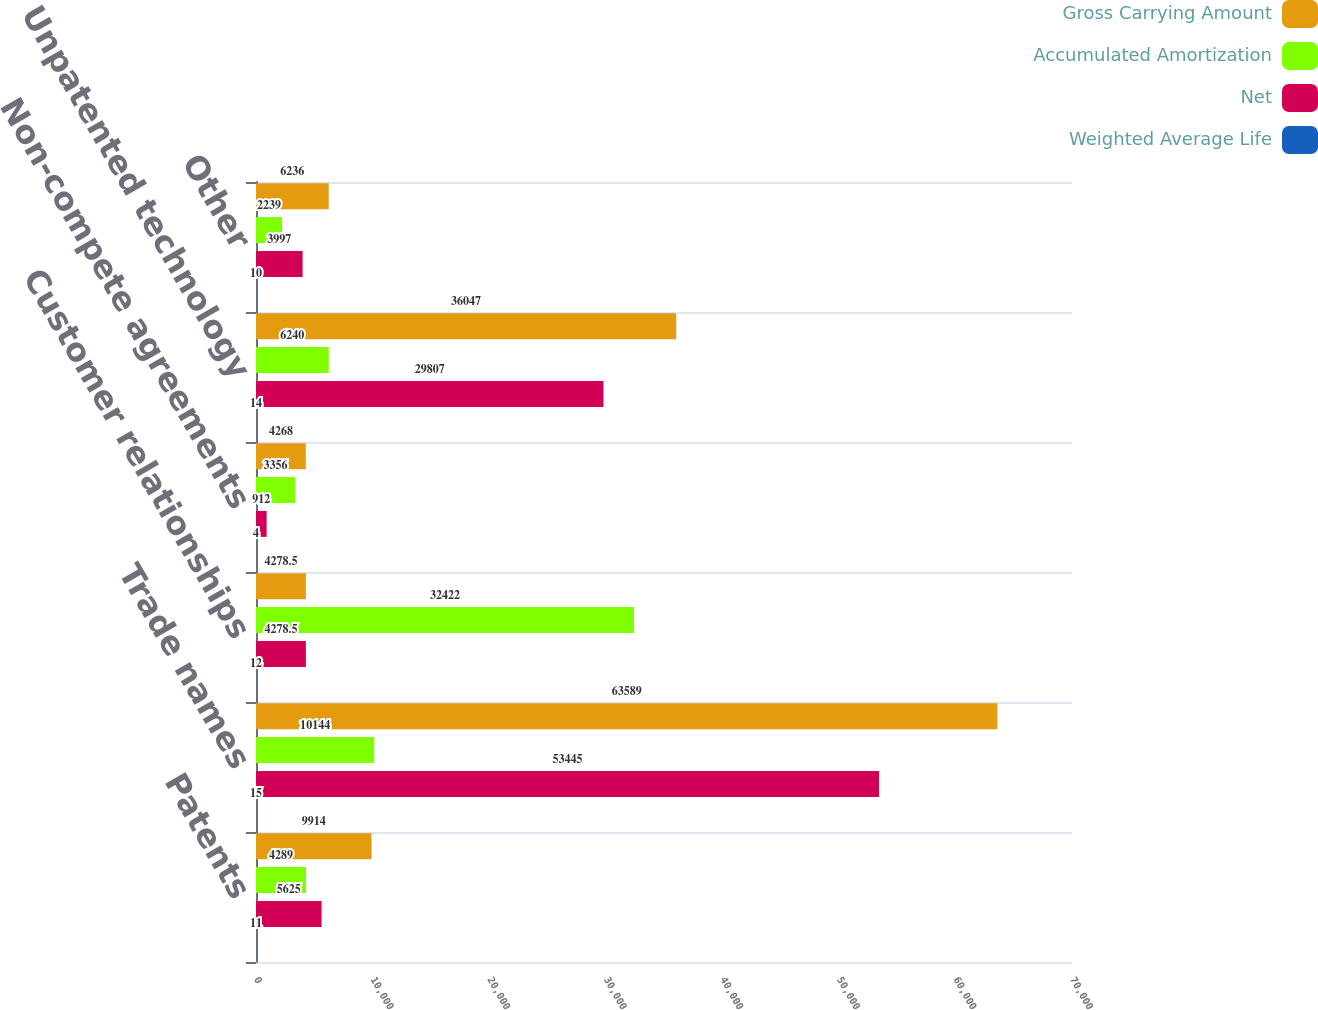Convert chart. <chart><loc_0><loc_0><loc_500><loc_500><stacked_bar_chart><ecel><fcel>Patents<fcel>Trade names<fcel>Customer relationships<fcel>Non-compete agreements<fcel>Unpatented technology<fcel>Other<nl><fcel>Gross Carrying Amount<fcel>9914<fcel>63589<fcel>4278.5<fcel>4268<fcel>36047<fcel>6236<nl><fcel>Accumulated Amortization<fcel>4289<fcel>10144<fcel>32422<fcel>3356<fcel>6240<fcel>2239<nl><fcel>Net<fcel>5625<fcel>53445<fcel>4278.5<fcel>912<fcel>29807<fcel>3997<nl><fcel>Weighted Average Life<fcel>11<fcel>15<fcel>12<fcel>4<fcel>14<fcel>10<nl></chart> 